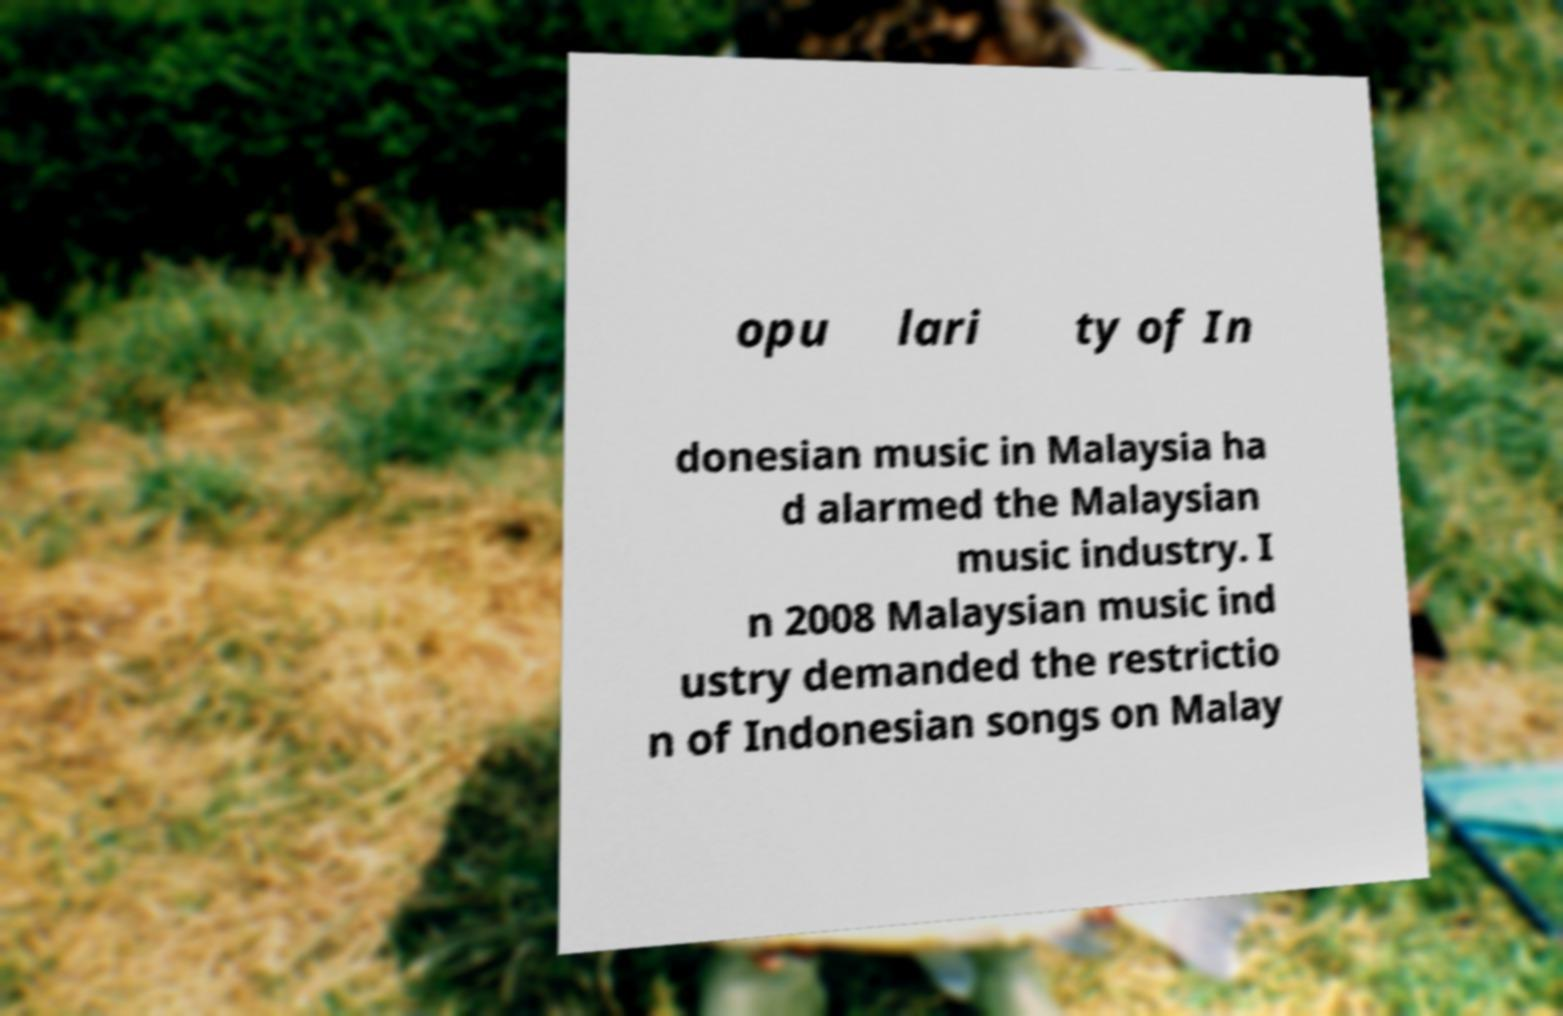Please identify and transcribe the text found in this image. opu lari ty of In donesian music in Malaysia ha d alarmed the Malaysian music industry. I n 2008 Malaysian music ind ustry demanded the restrictio n of Indonesian songs on Malay 